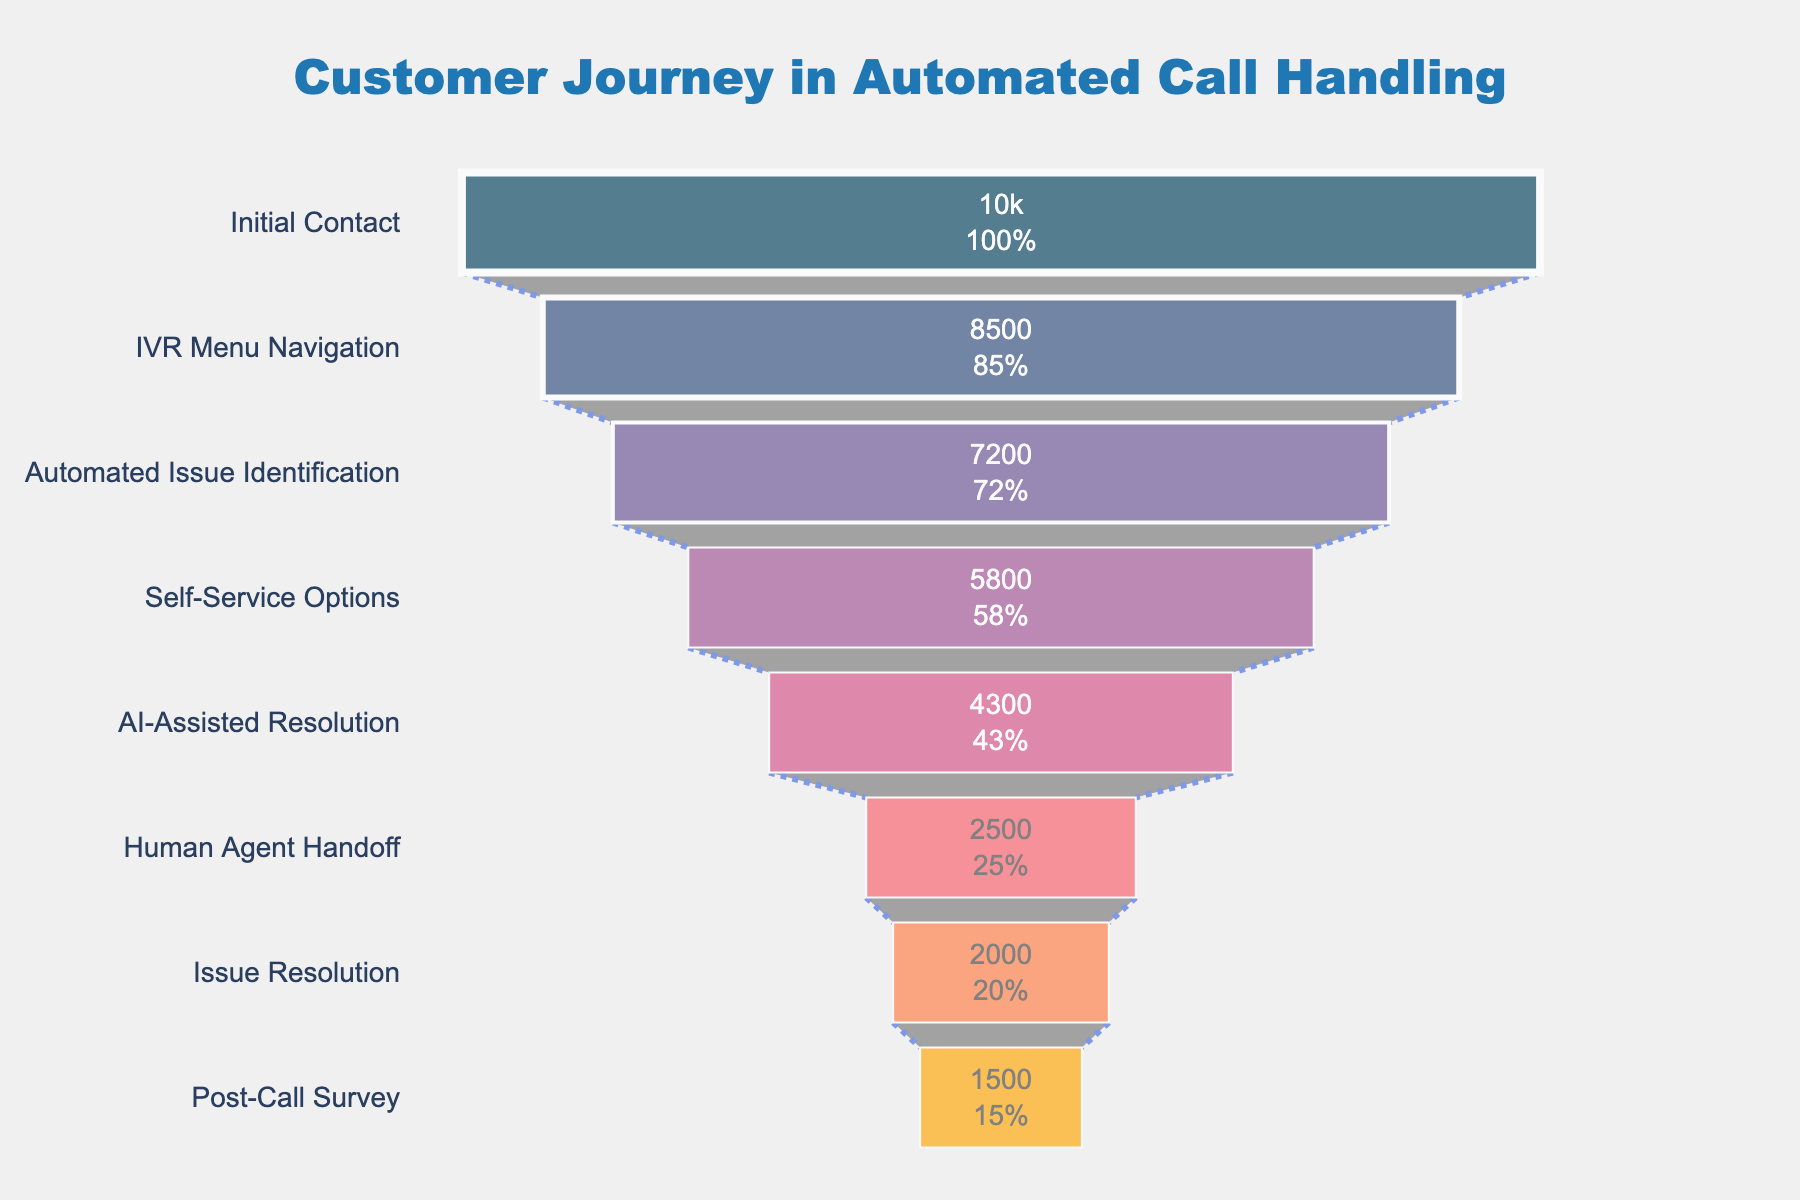What's the title of the funnel chart? The title of the graph is located at the top and centered in the chart layout. It provides a summary of what the figure represents.
Answer: Customer Journey in Automated Call Handling What percentage of initial contact customers proceed to the IVR Menu Navigation stage? The funnel chart displays the percentage of initial contacts proceeding to the next stage directly within the bars. The percentage text inside the funnel indicates this value.
Answer: 85% How many customers are lost between the Automated Issue Identification and Self-Service Options stages? Subtract the number of customers at the Self-Service Options stage from the number at the Automated Issue Identification stage: 7200 (Automated Issue Identification) - 5800 (Self-Service Options).
Answer: 1400 Which stage sees the most significant drop-off in customer numbers? The biggest drop-off can be identified by comparing the differences between consecutive stages. The largest difference indicates the most significant drop-off.
Answer: AI-Assisted Resolution to Human Agent Handoff What is the percentage drop from the Human Agent Handoff to Post-Call Survey stage? Calculate the percentage drop by first finding the difference in customers between the two stages: 2500 - 1500 = 1000. Then, divide this difference by the number at the earlier stage (2500) and multiply by 100 to find the percentage.
Answer: 40% How many customers reach AI-Assisted Resolution from initial contact? The chart indicates the exact count of customers reaching each stage from the initial contact, clearly shown within the stages.
Answer: 4300 Do more customers leave the process between the IVR Menu Navigation and Self-Service Options stages or between AI-Assisted Resolution and Issue Resolution stages? Calculate and compare the differences between customers at these stages: IVR to Self-Service: 8500 - 5800 = 2700 and AI-Assisted to Issue Resolution: 4300 - 2000 = 2300.
Answer: More customers leave between IVR to Self-Service Options What stage retains 72% of customers from the initial contact? Check the percentage values inside the funnel shapes to identify the stage that retains this exact amount.
Answer: Automated Issue Identification What are the colors used in representing the stages of the funnel? The colors for each stage are distinct and easily visible, ranging through a variation of hues for differentiation.
Answer: Shades of blue, purple, pink, red, orange What percentage of customers complete the Post-Call Survey according to the initial contact? The percentage shown inside the final funnel stage (Post-Call Survey) indicates how many customers completed this compared to the initial contact.
Answer: 15% 